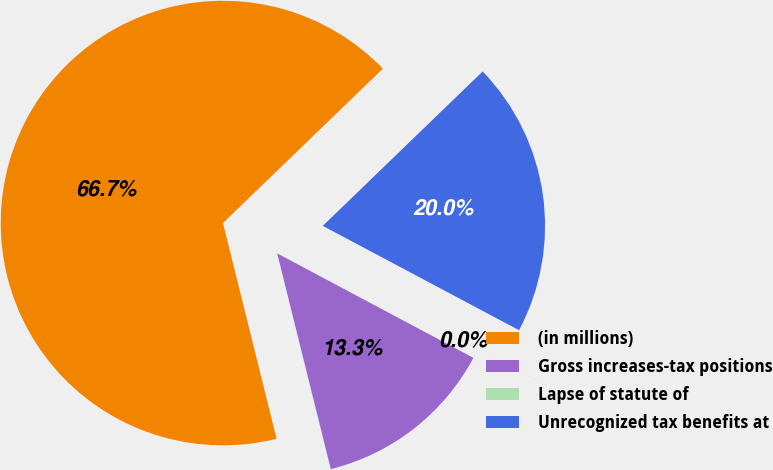Convert chart to OTSL. <chart><loc_0><loc_0><loc_500><loc_500><pie_chart><fcel>(in millions)<fcel>Gross increases-tax positions<fcel>Lapse of statute of<fcel>Unrecognized tax benefits at<nl><fcel>66.66%<fcel>13.34%<fcel>0.01%<fcel>20.0%<nl></chart> 